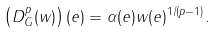<formula> <loc_0><loc_0><loc_500><loc_500>\left ( D _ { G } ^ { p } ( w ) \right ) ( e ) = \alpha ( e ) w ( e ) ^ { 1 / ( p - 1 ) } .</formula> 